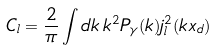Convert formula to latex. <formula><loc_0><loc_0><loc_500><loc_500>C _ { l } = \frac { 2 } { \pi } \int d k \, k ^ { 2 } P _ { \gamma } ( k ) j ^ { 2 } _ { l } ( k x _ { d } )</formula> 